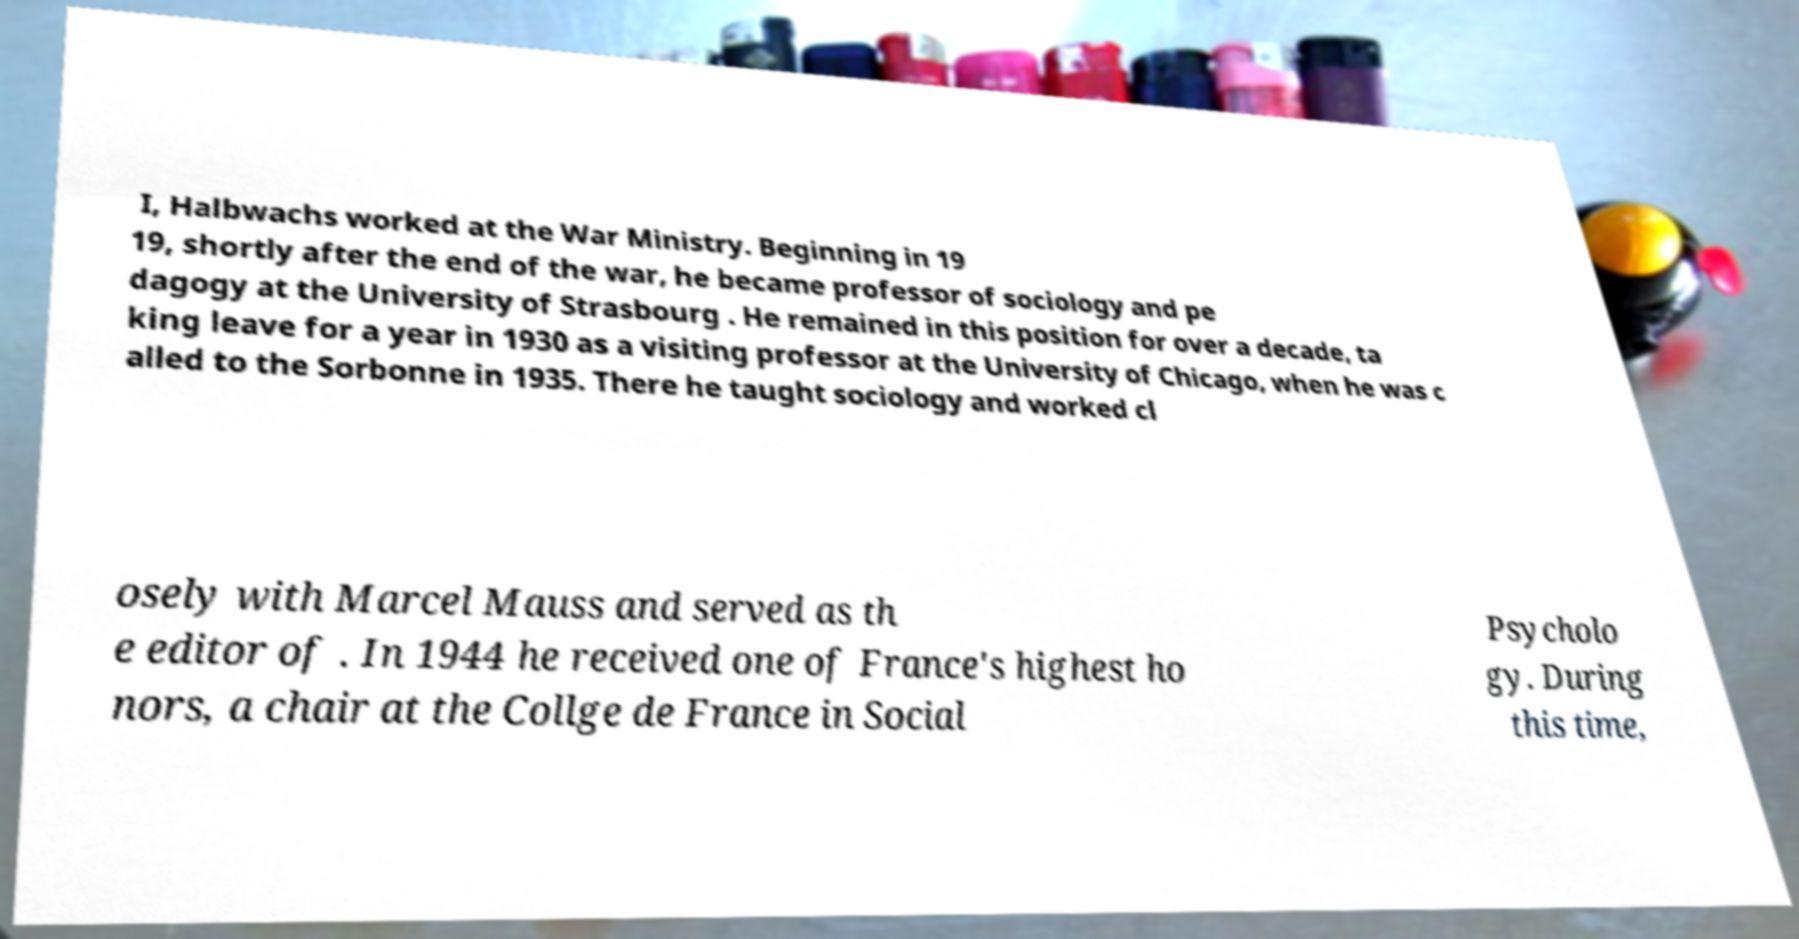I need the written content from this picture converted into text. Can you do that? I, Halbwachs worked at the War Ministry. Beginning in 19 19, shortly after the end of the war, he became professor of sociology and pe dagogy at the University of Strasbourg . He remained in this position for over a decade, ta king leave for a year in 1930 as a visiting professor at the University of Chicago, when he was c alled to the Sorbonne in 1935. There he taught sociology and worked cl osely with Marcel Mauss and served as th e editor of . In 1944 he received one of France's highest ho nors, a chair at the Collge de France in Social Psycholo gy. During this time, 